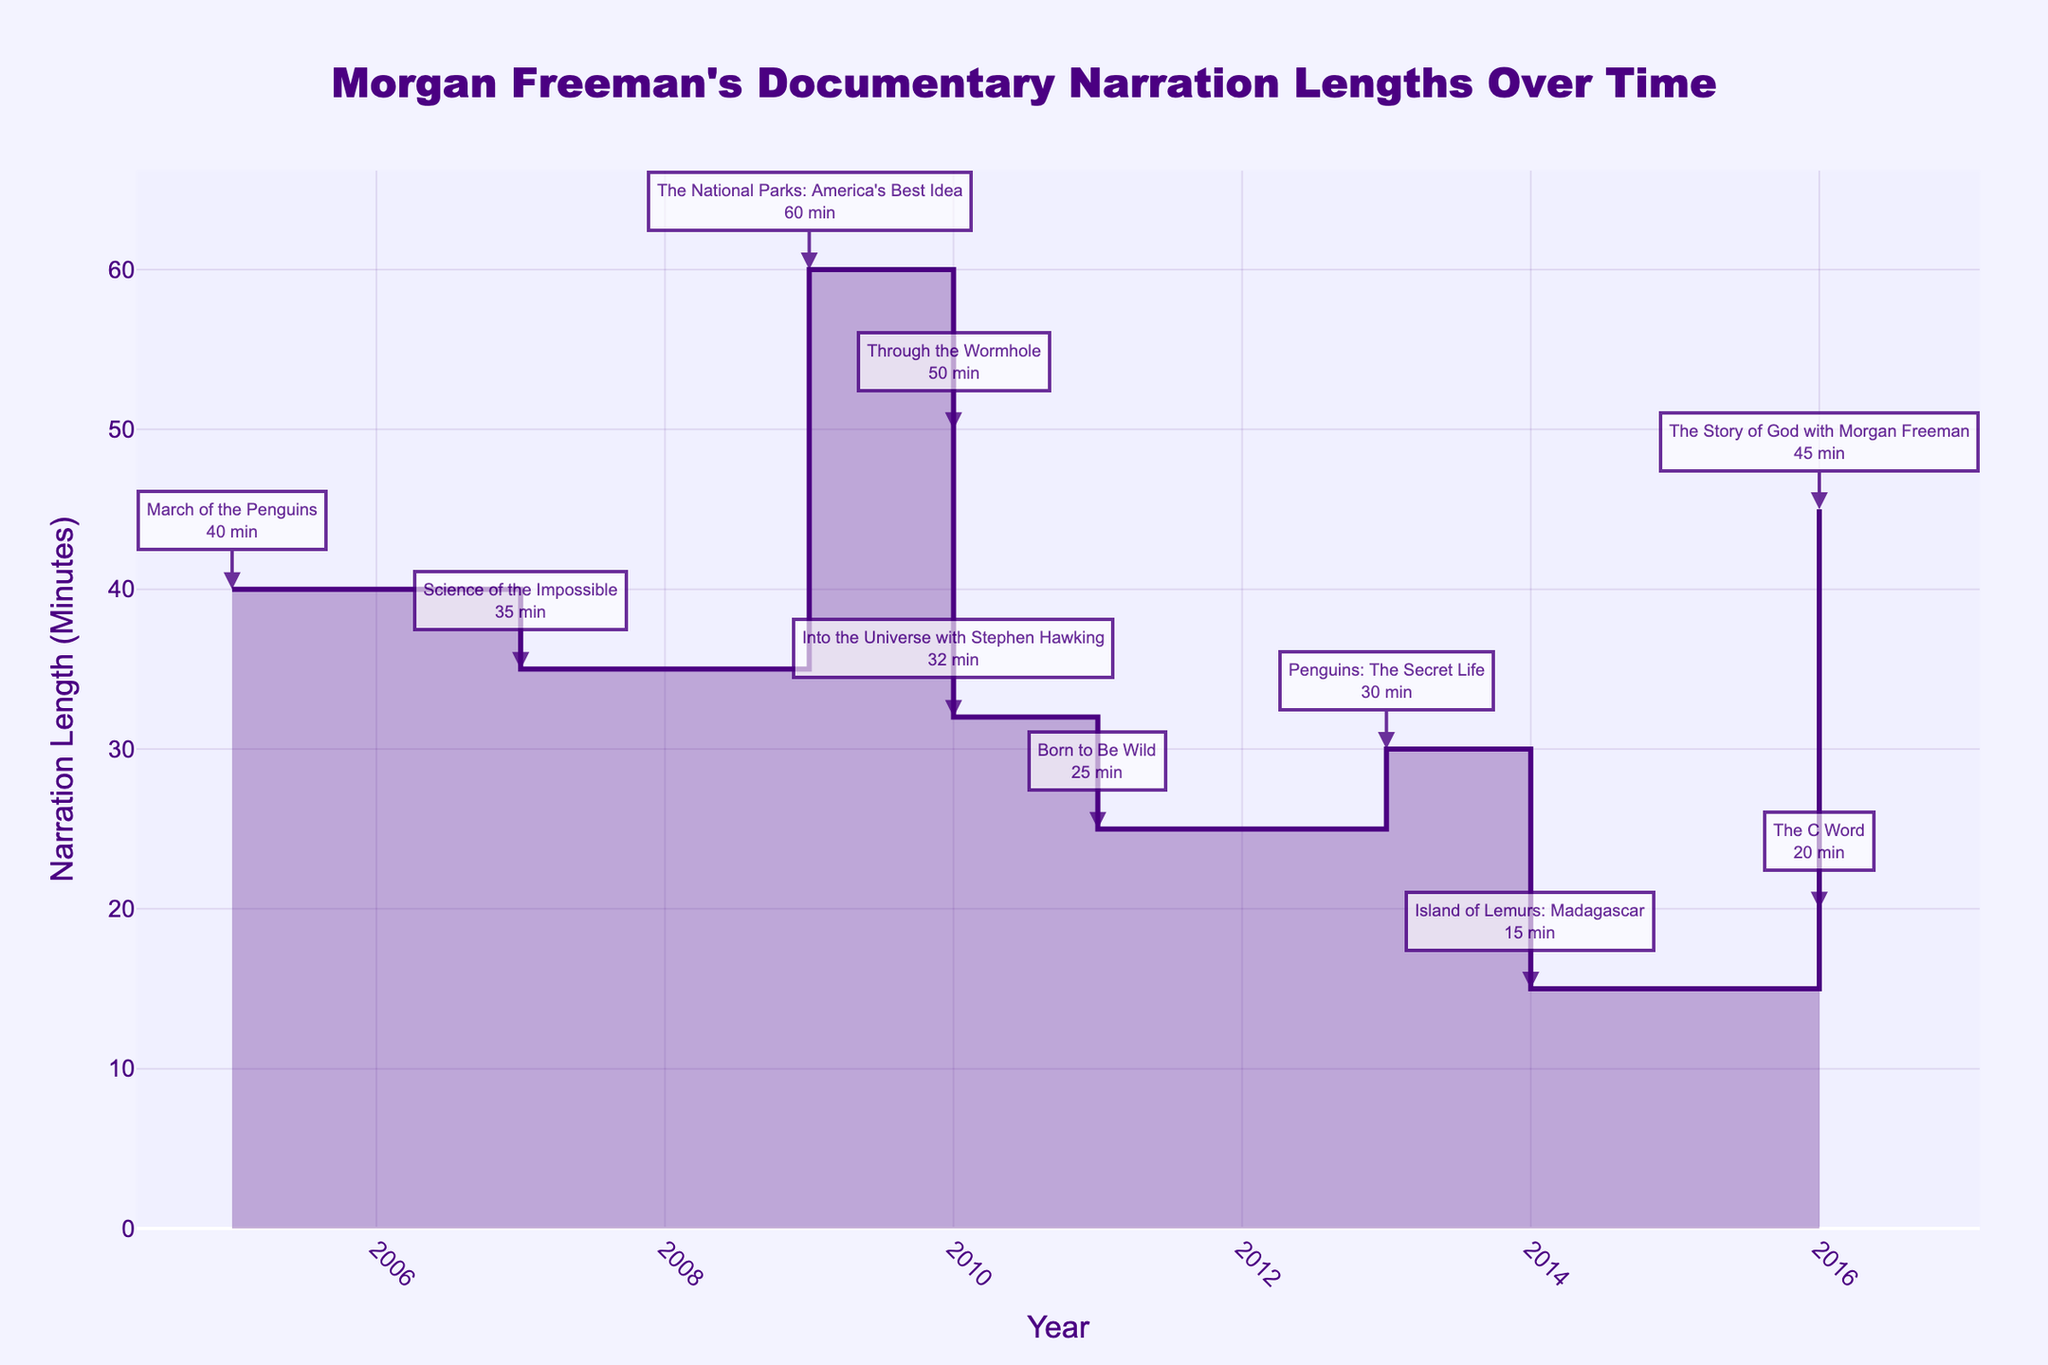What's the title of the figure? The title of the figure is usually displayed prominently at the top of the chart. In this case, the title is "Morgan Freeman's Documentary Narration Lengths Over Time".
Answer: Morgan Freeman's Documentary Narration Lengths Over Time What is the longest narration length recorded in the chart? The longest narration length can be found by identifying the highest point on the Y-axis of the chart. The annotation near the highest point indicates that it is "The National Parks: America's Best Idea" with a narration length of 60 minutes.
Answer: 60 minutes In which year did Morgan Freeman narrate the shortest documentary? By analyzing the chart, the lowest point on the Y-axis shows the shortest narration length. The annotation indicates that it is "Island of Lemurs: Madagascar" in 2014 with a narration length of 15 minutes.
Answer: 2014 What is the average narration length of the documentaries shown in the chart? To find the average, sum all the narration lengths and divide by the number of documentaries: (45 + 40 + 25 + 50 + 30 + 20 + 15 + 35 + 60 + 32) / 10 = 35.2
Answer: 35.2 minutes Which documentary had the longest narration length of 2010? By looking at the annotations for the year 2010, there are two documentaries: "Through the Wormhole" with 50 minutes and "Into the Universe with Stephen Hawking" with 32 minutes. "Through the Wormhole" has the longest narration.
Answer: Through the Wormhole Between which two consecutive years did the narration length increase the most? Observing the step changes in the chart, the biggest rise is between 2015 and 2016, where the narration length went from 20 minutes to 45 minutes for "The Story of God with Morgan Freeman".
Answer: 2015 and 2016 How many documentaries have a narration length of more than 30 minutes? Analyzing the Y-axis points and their corresponding annotations reveals that "The Story of God with Morgan Freeman" (45), "March of the Penguins" (40), "Through the Wormhole" (50), "The National Parks: America's Best Idea" (60), and "Science of the Impossible" (35) exceed 30 minutes.
Answer: 5 Which documentary narrated in 2016 has the shorter length, and by how much compared to the other one in the same year? In 2016, "The Story of God with Morgan Freeman" has 45 minutes and "The C Word" has 20 minutes. The difference is 45 - 20 = 25 minutes.
Answer: The C Word, 25 minutes When did the narration length reach exactly 40 minutes, and for which documentary? By checking the annotations for 40 minutes narration, it shows "March of the Penguins" in 2005.
Answer: 2005, March of the Penguins 